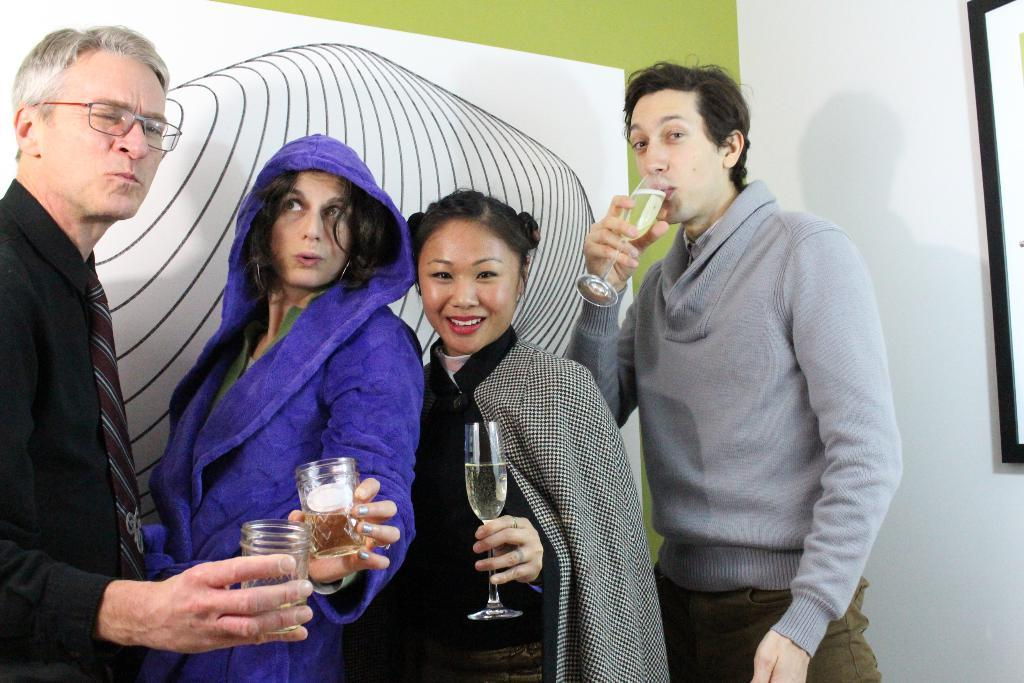What are the people holding in the image? The people are holding glasses with liquid in the image. Can you describe the wall in the image? There is a wall with a design in the image. What type of silk is being used to create the design on the wall in the image? There is no silk mentioned or visible in the image; the wall has a design, but the material used for the design is not specified. 